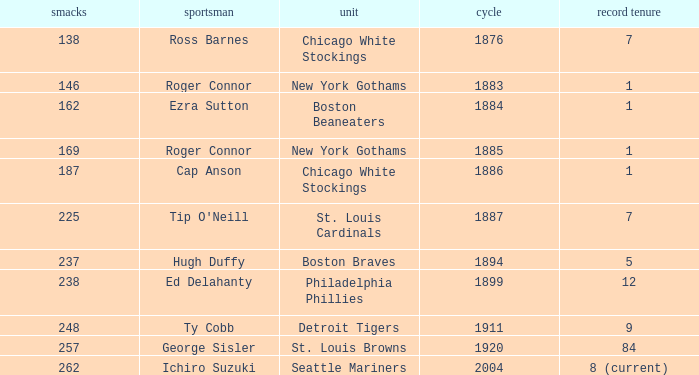Name the player with 238 hits and years after 1885 Ed Delahanty. 